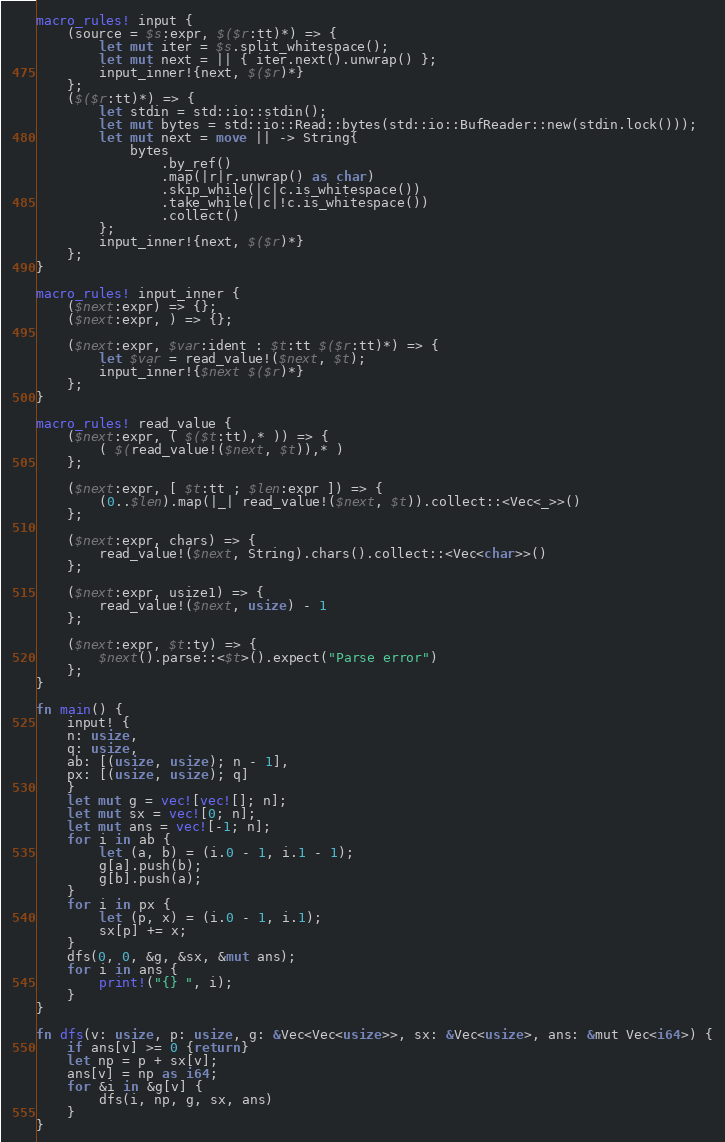Convert code to text. <code><loc_0><loc_0><loc_500><loc_500><_Rust_>macro_rules! input {
    (source = $s:expr, $($r:tt)*) => {
        let mut iter = $s.split_whitespace();
        let mut next = || { iter.next().unwrap() };
        input_inner!{next, $($r)*}
    };
    ($($r:tt)*) => {
        let stdin = std::io::stdin();
        let mut bytes = std::io::Read::bytes(std::io::BufReader::new(stdin.lock()));
        let mut next = move || -> String{
            bytes
                .by_ref()
                .map(|r|r.unwrap() as char)
                .skip_while(|c|c.is_whitespace())
                .take_while(|c|!c.is_whitespace())
                .collect()
        };
        input_inner!{next, $($r)*}
    };
}

macro_rules! input_inner {
    ($next:expr) => {};
    ($next:expr, ) => {};

    ($next:expr, $var:ident : $t:tt $($r:tt)*) => {
        let $var = read_value!($next, $t);
        input_inner!{$next $($r)*}
    };
}

macro_rules! read_value {
    ($next:expr, ( $($t:tt),* )) => {
        ( $(read_value!($next, $t)),* )
    };

    ($next:expr, [ $t:tt ; $len:expr ]) => {
        (0..$len).map(|_| read_value!($next, $t)).collect::<Vec<_>>()
    };

    ($next:expr, chars) => {
        read_value!($next, String).chars().collect::<Vec<char>>()
    };

    ($next:expr, usize1) => {
        read_value!($next, usize) - 1
    };

    ($next:expr, $t:ty) => {
        $next().parse::<$t>().expect("Parse error")
    };
}

fn main() {
    input! {
    n: usize,
    q: usize,
    ab: [(usize, usize); n - 1],
    px: [(usize, usize); q]
    }
    let mut g = vec![vec![]; n];
    let mut sx = vec![0; n];
    let mut ans = vec![-1; n];
    for i in ab {
        let (a, b) = (i.0 - 1, i.1 - 1);
        g[a].push(b);
        g[b].push(a);
    }
    for i in px {
        let (p, x) = (i.0 - 1, i.1);
        sx[p] += x;
    }
    dfs(0, 0, &g, &sx, &mut ans);
    for i in ans {
        print!("{} ", i);
    }
}

fn dfs(v: usize, p: usize, g: &Vec<Vec<usize>>, sx: &Vec<usize>, ans: &mut Vec<i64>) {
    if ans[v] >= 0 {return}
    let np = p + sx[v];
    ans[v] = np as i64;
    for &i in &g[v] {
        dfs(i, np, g, sx, ans)
    }
}

</code> 